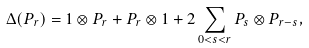<formula> <loc_0><loc_0><loc_500><loc_500>\Delta ( P _ { r } ) = 1 \otimes P _ { r } + P _ { r } \otimes 1 + 2 \sum _ { 0 < s < r } P _ { s } \otimes P _ { r - s } ,</formula> 